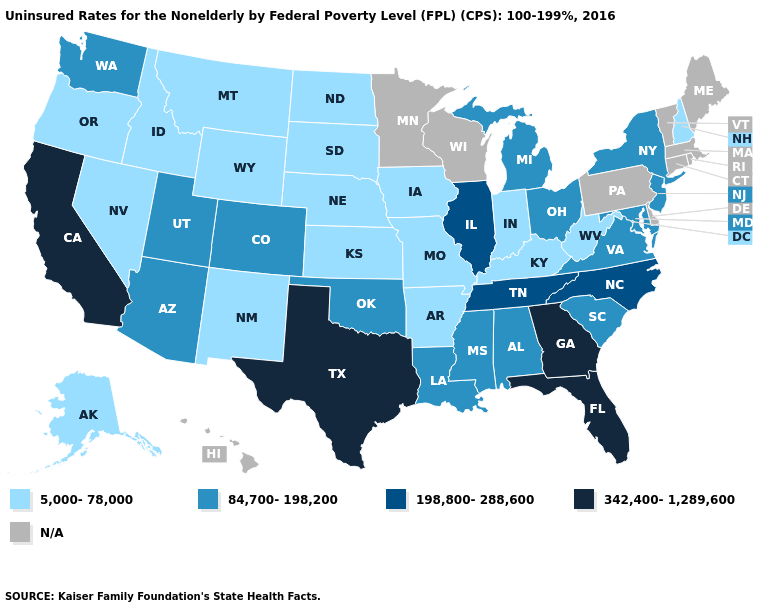What is the value of Indiana?
Keep it brief. 5,000-78,000. Name the states that have a value in the range 198,800-288,600?
Quick response, please. Illinois, North Carolina, Tennessee. What is the highest value in the West ?
Give a very brief answer. 342,400-1,289,600. Name the states that have a value in the range 342,400-1,289,600?
Give a very brief answer. California, Florida, Georgia, Texas. Name the states that have a value in the range 342,400-1,289,600?
Write a very short answer. California, Florida, Georgia, Texas. Does New Hampshire have the lowest value in the Northeast?
Concise answer only. Yes. What is the value of New York?
Give a very brief answer. 84,700-198,200. Among the states that border Idaho , does Washington have the lowest value?
Concise answer only. No. What is the value of Indiana?
Give a very brief answer. 5,000-78,000. Does New York have the lowest value in the USA?
Answer briefly. No. Name the states that have a value in the range 198,800-288,600?
Write a very short answer. Illinois, North Carolina, Tennessee. Among the states that border South Carolina , does Georgia have the lowest value?
Short answer required. No. What is the highest value in the USA?
Be succinct. 342,400-1,289,600. What is the value of Alabama?
Quick response, please. 84,700-198,200. Among the states that border New Mexico , which have the lowest value?
Answer briefly. Arizona, Colorado, Oklahoma, Utah. 